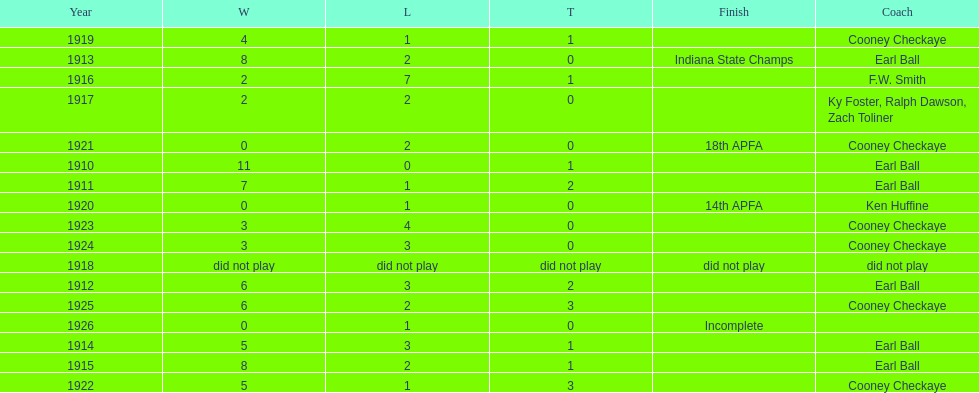Write the full table. {'header': ['Year', 'W', 'L', 'T', 'Finish', 'Coach'], 'rows': [['1919', '4', '1', '1', '', 'Cooney Checkaye'], ['1913', '8', '2', '0', 'Indiana State Champs', 'Earl Ball'], ['1916', '2', '7', '1', '', 'F.W. Smith'], ['1917', '2', '2', '0', '', 'Ky Foster, Ralph Dawson, Zach Toliner'], ['1921', '0', '2', '0', '18th APFA', 'Cooney Checkaye'], ['1910', '11', '0', '1', '', 'Earl Ball'], ['1911', '7', '1', '2', '', 'Earl Ball'], ['1920', '0', '1', '0', '14th APFA', 'Ken Huffine'], ['1923', '3', '4', '0', '', 'Cooney Checkaye'], ['1924', '3', '3', '0', '', 'Cooney Checkaye'], ['1918', 'did not play', 'did not play', 'did not play', 'did not play', 'did not play'], ['1912', '6', '3', '2', '', 'Earl Ball'], ['1925', '6', '2', '3', '', 'Cooney Checkaye'], ['1926', '0', '1', '0', 'Incomplete', ''], ['1914', '5', '3', '1', '', 'Earl Ball'], ['1915', '8', '2', '1', '', 'Earl Ball'], ['1922', '5', '1', '3', '', 'Cooney Checkaye']]} How many years did cooney checkaye coach the muncie flyers? 6. 